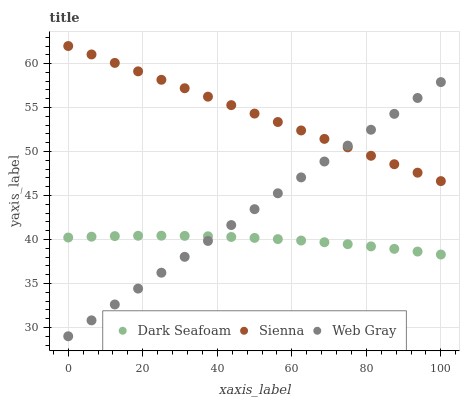Does Dark Seafoam have the minimum area under the curve?
Answer yes or no. Yes. Does Sienna have the maximum area under the curve?
Answer yes or no. Yes. Does Web Gray have the minimum area under the curve?
Answer yes or no. No. Does Web Gray have the maximum area under the curve?
Answer yes or no. No. Is Web Gray the smoothest?
Answer yes or no. Yes. Is Dark Seafoam the roughest?
Answer yes or no. Yes. Is Dark Seafoam the smoothest?
Answer yes or no. No. Is Web Gray the roughest?
Answer yes or no. No. Does Web Gray have the lowest value?
Answer yes or no. Yes. Does Dark Seafoam have the lowest value?
Answer yes or no. No. Does Sienna have the highest value?
Answer yes or no. Yes. Does Web Gray have the highest value?
Answer yes or no. No. Is Dark Seafoam less than Sienna?
Answer yes or no. Yes. Is Sienna greater than Dark Seafoam?
Answer yes or no. Yes. Does Dark Seafoam intersect Web Gray?
Answer yes or no. Yes. Is Dark Seafoam less than Web Gray?
Answer yes or no. No. Is Dark Seafoam greater than Web Gray?
Answer yes or no. No. Does Dark Seafoam intersect Sienna?
Answer yes or no. No. 